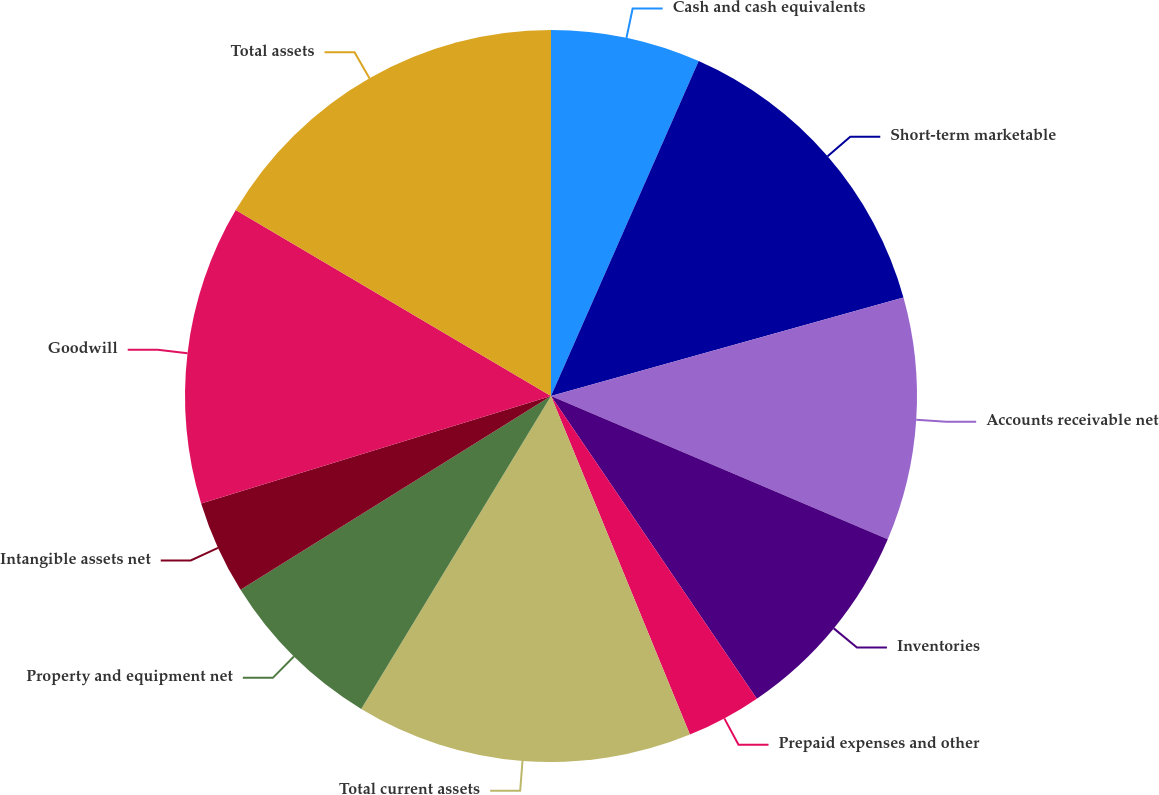Convert chart to OTSL. <chart><loc_0><loc_0><loc_500><loc_500><pie_chart><fcel>Cash and cash equivalents<fcel>Short-term marketable<fcel>Accounts receivable net<fcel>Inventories<fcel>Prepaid expenses and other<fcel>Total current assets<fcel>Property and equipment net<fcel>Intangible assets net<fcel>Goodwill<fcel>Total assets<nl><fcel>6.61%<fcel>14.05%<fcel>10.74%<fcel>9.09%<fcel>3.31%<fcel>14.87%<fcel>7.44%<fcel>4.14%<fcel>13.22%<fcel>16.52%<nl></chart> 